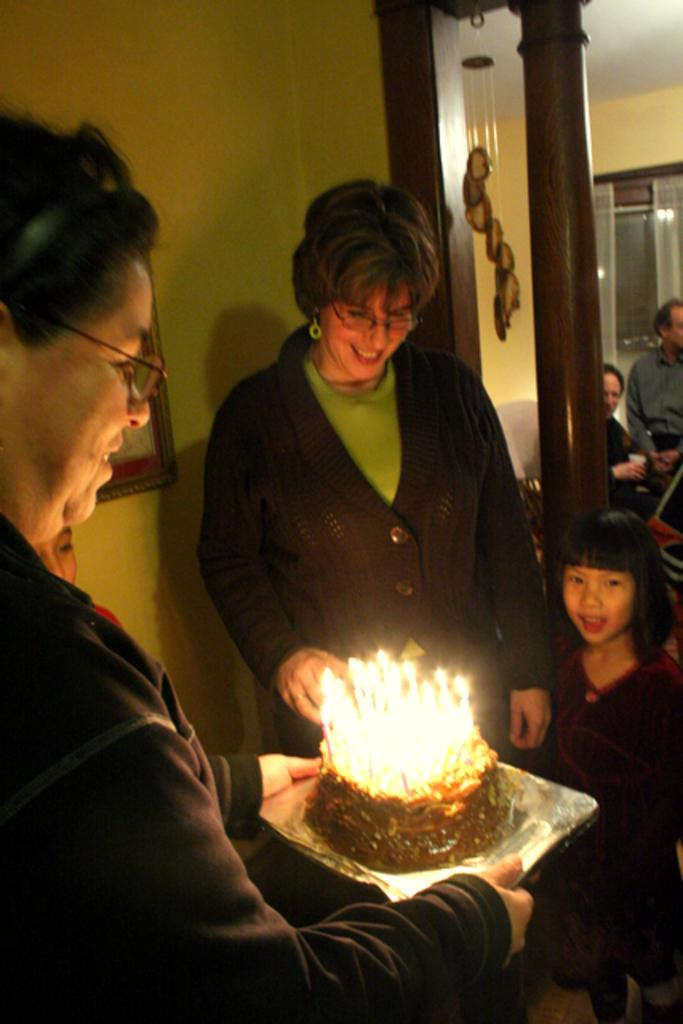What are the people in the image doing? There are people standing in the image, and one person is holding a plate with cake and candles. What is on the plate that the person is holding? The plate has cake and candles on it. What can be seen on the wall in the image? There is a frame on a wall in the image. What is visible in the background of the image? The background of the image includes people and a window. What type of window treatment is present in the image? There are curtains associated with the window. What type of statement can be seen on the cake in the image? There is no statement visible on the cake in the image; it only has candles. How many frogs are present in the image? There are no frogs present in the image. 